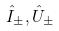<formula> <loc_0><loc_0><loc_500><loc_500>\hat { I } _ { \pm } , \hat { U } _ { \pm }</formula> 